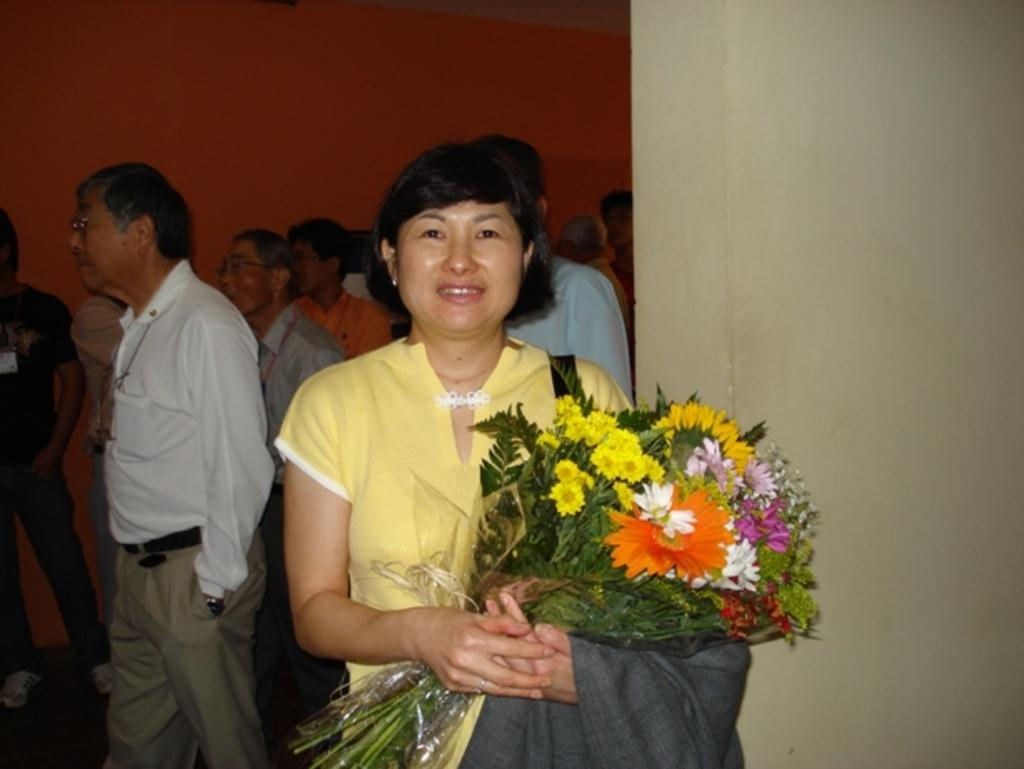Who is the main subject in the image? There is a lady in the image. What is the lady holding in the image? The lady is holding a flower bouquet and a coat. What can be seen in the background of the image? There are many people and a wall in the background of the image. What type of thing is hanging from the icicle in the image? There is no icicle present in the image, so it is not possible to answer that question. 